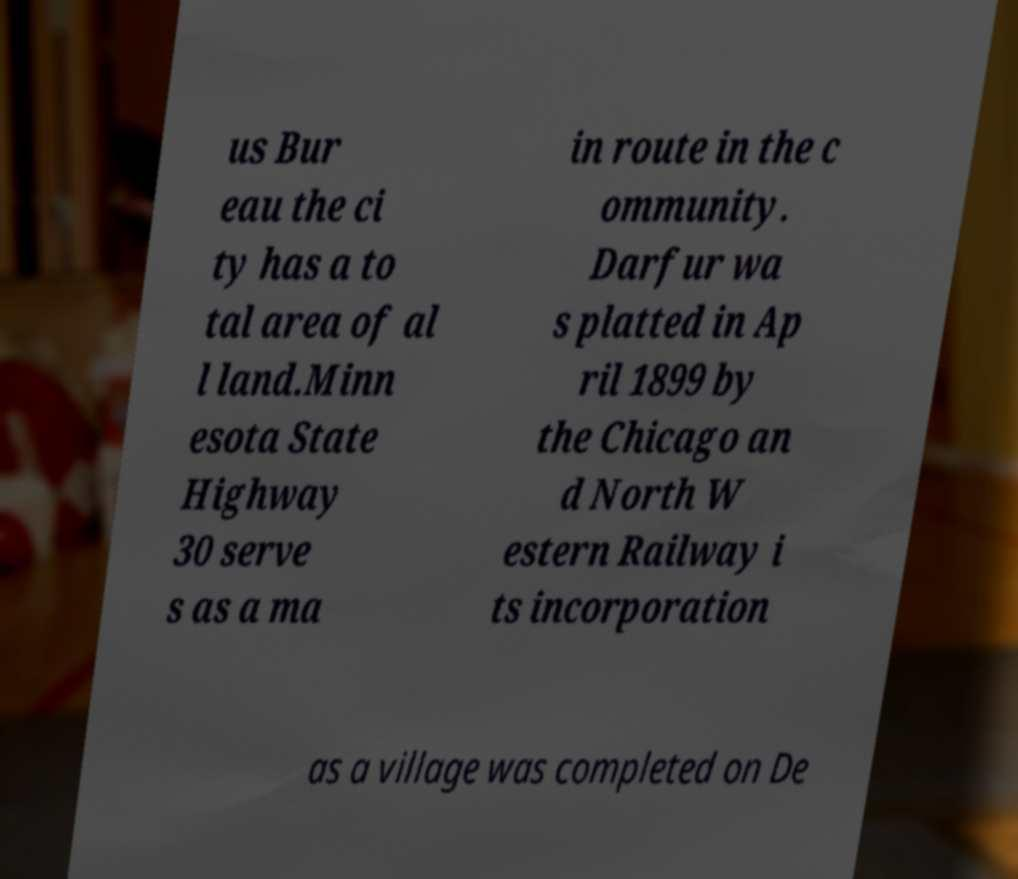Can you read and provide the text displayed in the image?This photo seems to have some interesting text. Can you extract and type it out for me? us Bur eau the ci ty has a to tal area of al l land.Minn esota State Highway 30 serve s as a ma in route in the c ommunity. Darfur wa s platted in Ap ril 1899 by the Chicago an d North W estern Railway i ts incorporation as a village was completed on De 